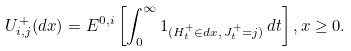Convert formula to latex. <formula><loc_0><loc_0><loc_500><loc_500>U ^ { + } _ { i , j } ( d x ) = { E } ^ { 0 , i } \left [ \int _ { 0 } ^ { \infty } 1 _ { ( H ^ { + } _ { t } \in d x , \, J ^ { + } _ { t } = j ) } \, d t \right ] , x \geq 0 .</formula> 